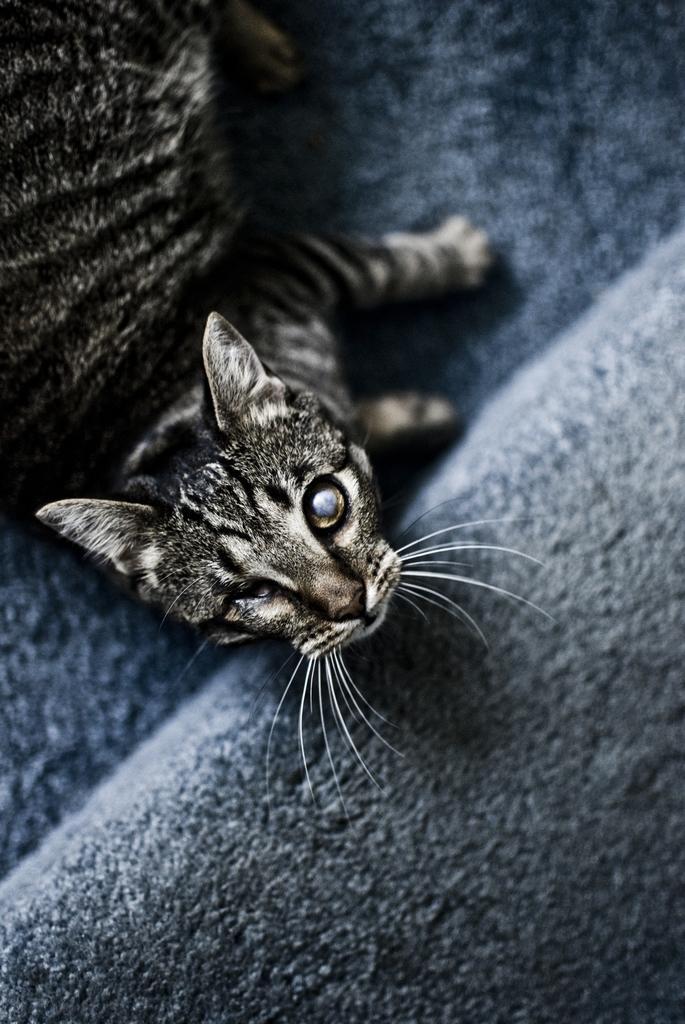How would you summarize this image in a sentence or two? In this image a cat is lying on the sofa which is blue color. 